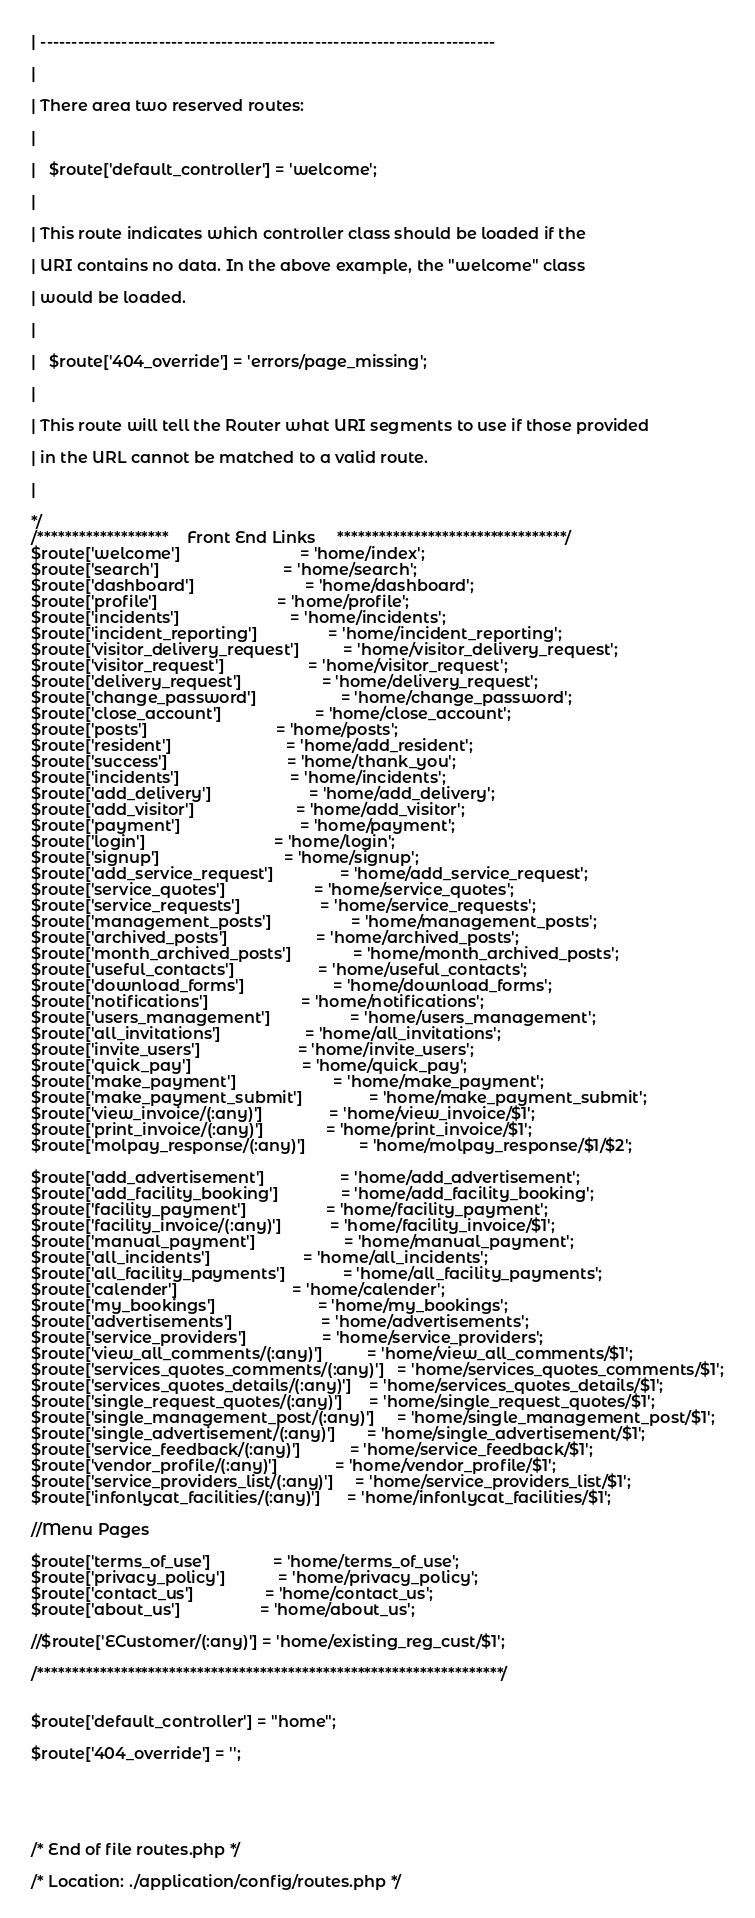<code> <loc_0><loc_0><loc_500><loc_500><_PHP_>
| -------------------------------------------------------------------------

|

| There area two reserved routes:

|

|	$route['default_controller'] = 'welcome';

|

| This route indicates which controller class should be loaded if the

| URI contains no data. In the above example, the "welcome" class

| would be loaded.

|

|	$route['404_override'] = 'errors/page_missing';

|

| This route will tell the Router what URI segments to use if those provided

| in the URL cannot be matched to a valid route.

|

*/
/*******************	Front End Links		*********************************/
$route['welcome'] 							= 'home/index';
$route['search'] 							= 'home/search';
$route['dashboard'] 						= 'home/dashboard';
$route['profile'] 							= 'home/profile';
$route['incidents'] 						= 'home/incidents';
$route['incident_reporting'] 				= 'home/incident_reporting';
$route['visitor_delivery_request'] 			= 'home/visitor_delivery_request';
$route['visitor_request'] 					= 'home/visitor_request';
$route['delivery_request'] 					= 'home/delivery_request';
$route['change_password'] 					= 'home/change_password';
$route['close_account'] 					= 'home/close_account';
$route['posts'] 							= 'home/posts';
$route['resident'] 							= 'home/add_resident';
$route['success'] 							= 'home/thank_you';
$route['incidents'] 						= 'home/incidents';
$route['add_delivery'] 						= 'home/add_delivery';
$route['add_visitor'] 						= 'home/add_visitor';
$route['payment'] 							= 'home/payment';
$route['login'] 							= 'home/login';
$route['signup'] 							= 'home/signup';
$route['add_service_request'] 				= 'home/add_service_request';
$route['service_quotes'] 					= 'home/service_quotes';
$route['service_requests'] 					= 'home/service_requests';
$route['management_posts'] 					= 'home/management_posts';
$route['archived_posts'] 					= 'home/archived_posts';
$route['month_archived_posts'] 				= 'home/month_archived_posts';
$route['useful_contacts'] 					= 'home/useful_contacts';
$route['download_forms'] 					= 'home/download_forms';
$route['notifications'] 					= 'home/notifications';
$route['users_management'] 					= 'home/users_management';
$route['all_invitations'] 					= 'home/all_invitations';
$route['invite_users'] 						= 'home/invite_users';
$route['quick_pay'] 						= 'home/quick_pay';
$route['make_payment'] 						= 'home/make_payment';
$route['make_payment_submit'] 				= 'home/make_payment_submit';
$route['view_invoice/(:any)'] 				= 'home/view_invoice/$1';
$route['print_invoice/(:any)'] 				= 'home/print_invoice/$1';
$route['molpay_response/(:any)']			= 'home/molpay_response/$1/$2';

$route['add_advertisement'] 				= 'home/add_advertisement';
$route['add_facility_booking'] 				= 'home/add_facility_booking';
$route['facility_payment'] 					= 'home/facility_payment';
$route['facility_invoice/(:any)'] 			= 'home/facility_invoice/$1';
$route['manual_payment'] 					= 'home/manual_payment';
$route['all_incidents'] 					= 'home/all_incidents';
$route['all_facility_payments'] 			= 'home/all_facility_payments';
$route['calender'] 							= 'home/calender';
$route['my_bookings'] 						= 'home/my_bookings';
$route['advertisements'] 					= 'home/advertisements';
$route['service_providers'] 				= 'home/service_providers';
$route['view_all_comments/(:any)'] 			= 'home/view_all_comments/$1';
$route['services_quotes_comments/(:any)'] 	= 'home/services_quotes_comments/$1';
$route['services_quotes_details/(:any)'] 	= 'home/services_quotes_details/$1';
$route['single_request_quotes/(:any)'] 		= 'home/single_request_quotes/$1';
$route['single_management_post/(:any)'] 	= 'home/single_management_post/$1';
$route['single_advertisement/(:any)'] 		= 'home/single_advertisement/$1';
$route['service_feedback/(:any)'] 			= 'home/service_feedback/$1';
$route['vendor_profile/(:any)'] 			= 'home/vendor_profile/$1';
$route['service_providers_list/(:any)'] 	= 'home/service_providers_list/$1';
$route['infonlycat_facilities/(:any)'] 		= 'home/infonlycat_facilities/$1';

//Menu Pages

$route['terms_of_use'] 				= 'home/terms_of_use';
$route['privacy_policy'] 			= 'home/privacy_policy';
$route['contact_us'] 				= 'home/contact_us';
$route['about_us']                  = 'home/about_us';

//$route['ECustomer/(:any)'] = 'home/existing_reg_cust/$1';

/*******************************************************************/


$route['default_controller'] = "home";

$route['404_override'] = '';





/* End of file routes.php */

/* Location: ./application/config/routes.php */</code> 